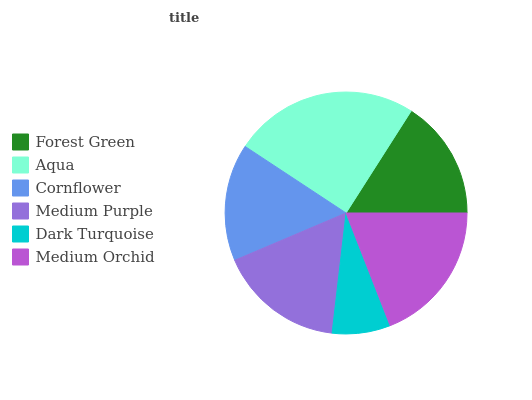Is Dark Turquoise the minimum?
Answer yes or no. Yes. Is Aqua the maximum?
Answer yes or no. Yes. Is Cornflower the minimum?
Answer yes or no. No. Is Cornflower the maximum?
Answer yes or no. No. Is Aqua greater than Cornflower?
Answer yes or no. Yes. Is Cornflower less than Aqua?
Answer yes or no. Yes. Is Cornflower greater than Aqua?
Answer yes or no. No. Is Aqua less than Cornflower?
Answer yes or no. No. Is Medium Purple the high median?
Answer yes or no. Yes. Is Forest Green the low median?
Answer yes or no. Yes. Is Medium Orchid the high median?
Answer yes or no. No. Is Dark Turquoise the low median?
Answer yes or no. No. 